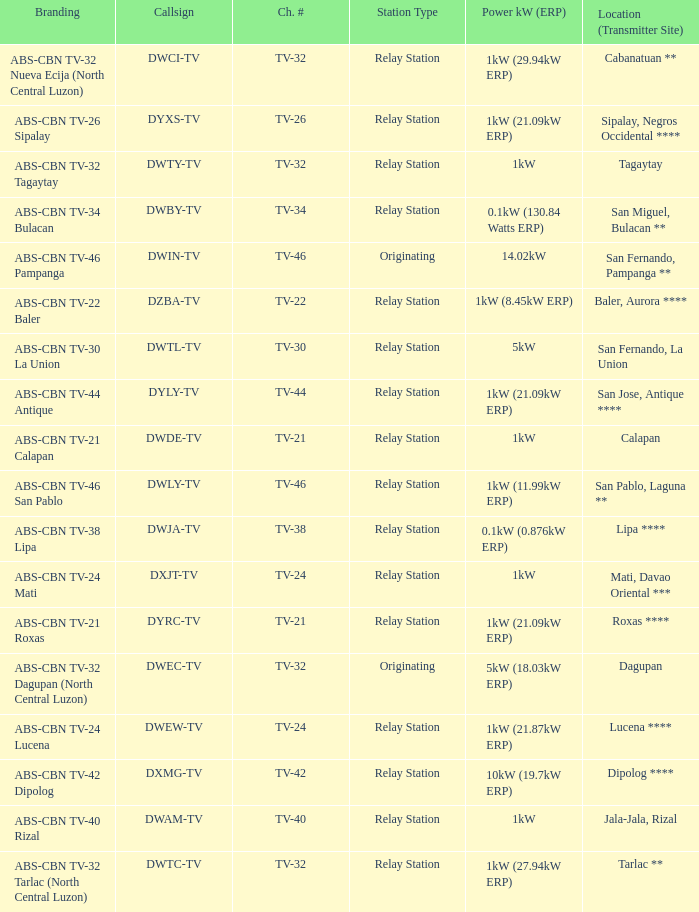How many brandings have a 1kw (29.94kw erp) power kw (erp)? 1.0. 